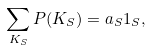<formula> <loc_0><loc_0><loc_500><loc_500>\sum _ { K _ { S } } P ( K _ { S } ) = a _ { S } 1 _ { S } ,</formula> 